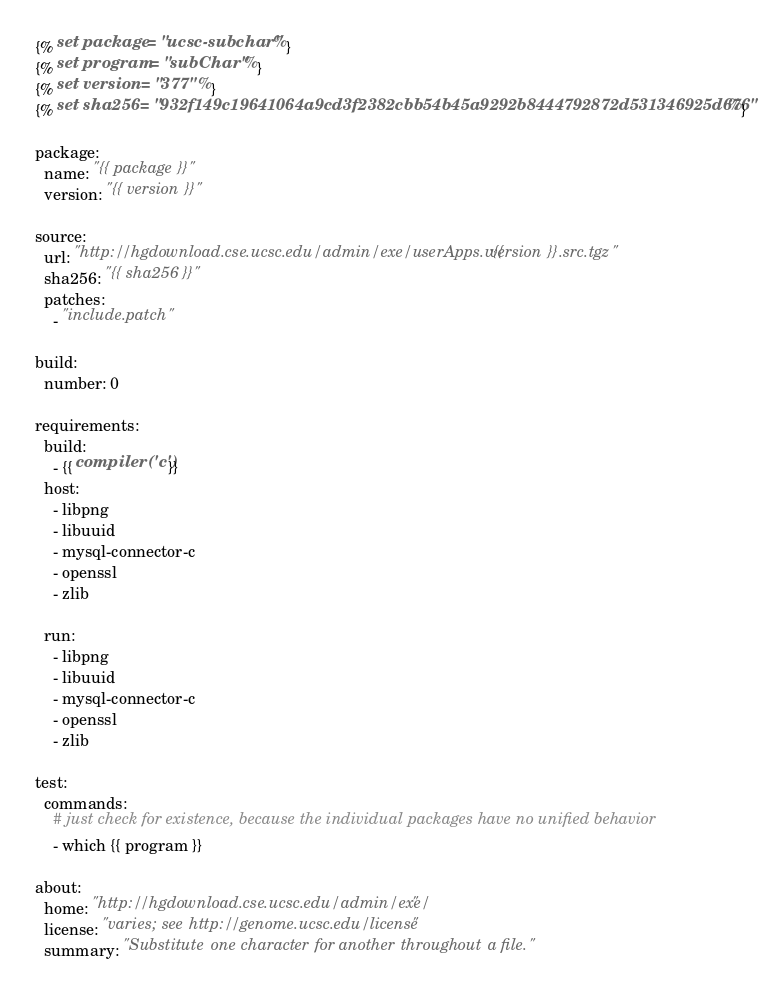Convert code to text. <code><loc_0><loc_0><loc_500><loc_500><_YAML_>{% set package = "ucsc-subchar" %}
{% set program = "subChar" %}
{% set version = "377" %}
{% set sha256 = "932f149c19641064a9cd3f2382cbb54b45a9292b8444792872d531346925d676" %}

package:
  name: "{{ package }}"
  version: "{{ version }}"

source:
  url: "http://hgdownload.cse.ucsc.edu/admin/exe/userApps.v{{ version }}.src.tgz"
  sha256: "{{ sha256 }}"
  patches:
    - "include.patch"

build:
  number: 0

requirements:
  build:
    - {{ compiler('c') }}
  host:
    - libpng
    - libuuid
    - mysql-connector-c
    - openssl
    - zlib

  run:
    - libpng
    - libuuid
    - mysql-connector-c
    - openssl
    - zlib

test:
  commands:
    # just check for existence, because the individual packages have no unified behavior
    - which {{ program }}

about:
  home: "http://hgdownload.cse.ucsc.edu/admin/exe/"
  license: "varies; see http://genome.ucsc.edu/license"
  summary: "Substitute one character for another throughout a file."
</code> 